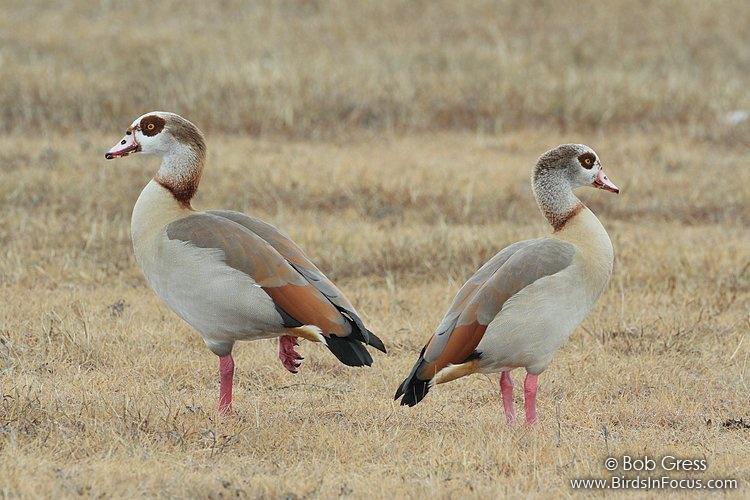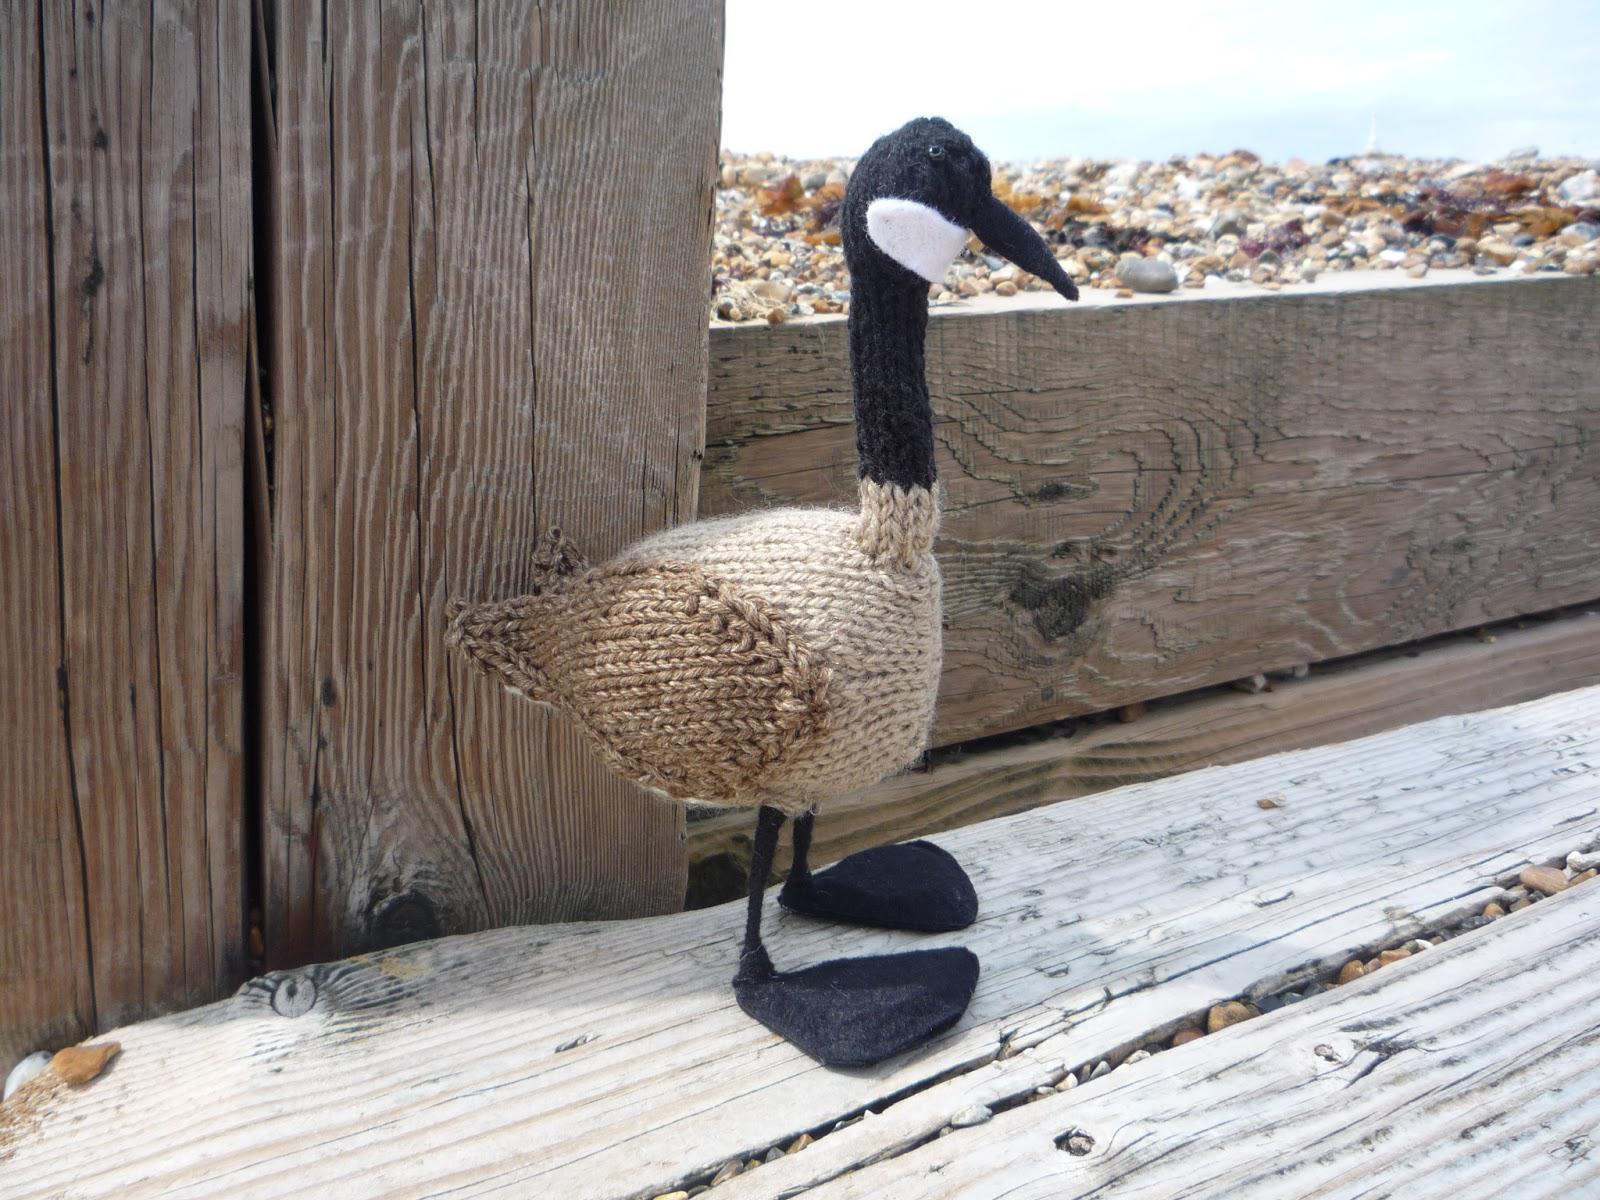The first image is the image on the left, the second image is the image on the right. Assess this claim about the two images: "None of the birds are standing on wood or snow.". Correct or not? Answer yes or no. No. The first image is the image on the left, the second image is the image on the right. Considering the images on both sides, is "All birds are standing, and all birds are 'real' living animals." valid? Answer yes or no. No. 